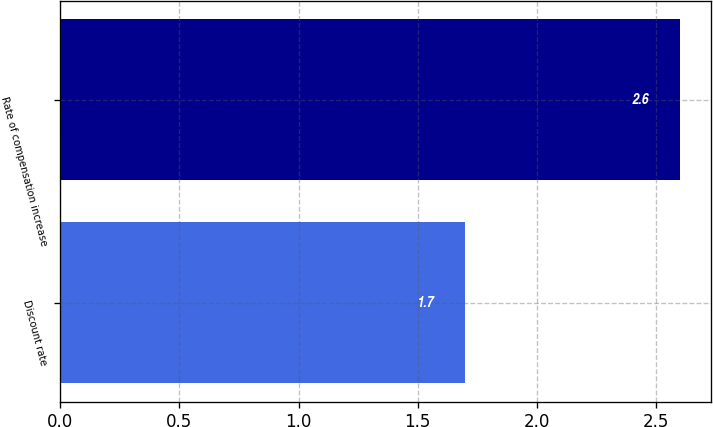<chart> <loc_0><loc_0><loc_500><loc_500><bar_chart><fcel>Discount rate<fcel>Rate of compensation increase<nl><fcel>1.7<fcel>2.6<nl></chart> 